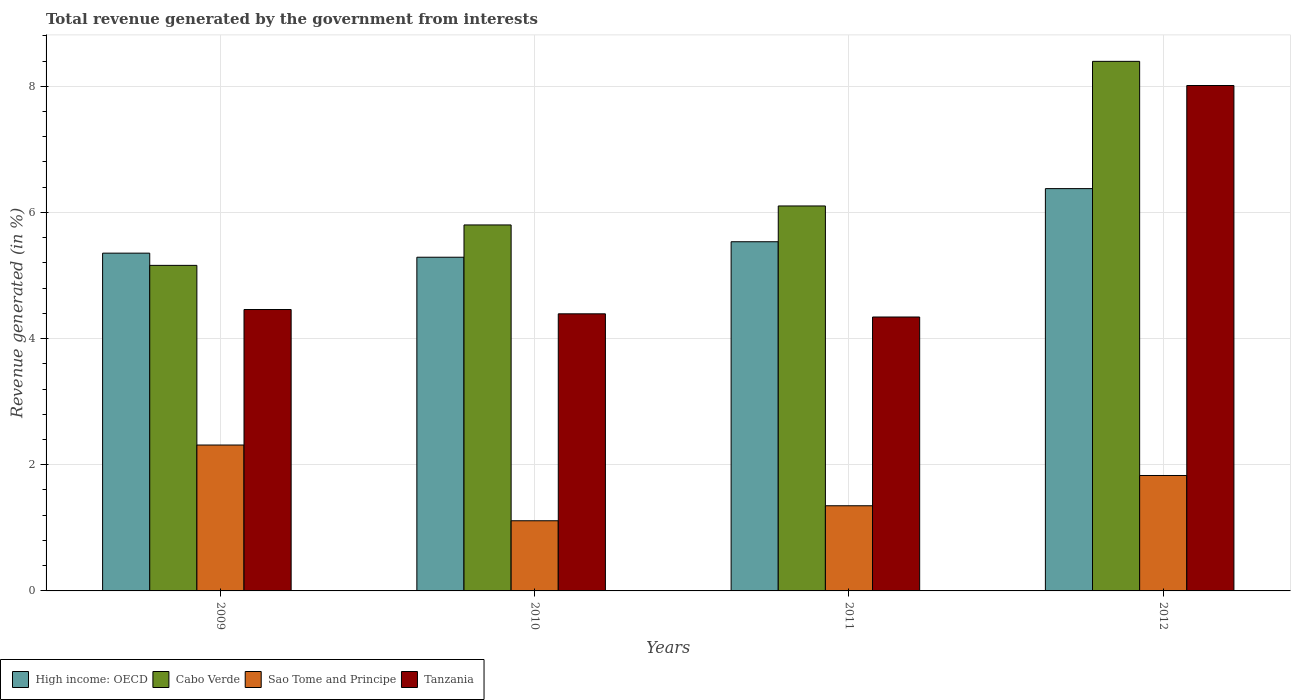How many different coloured bars are there?
Your answer should be very brief. 4. How many groups of bars are there?
Ensure brevity in your answer.  4. Are the number of bars on each tick of the X-axis equal?
Provide a short and direct response. Yes. How many bars are there on the 4th tick from the left?
Provide a succinct answer. 4. In how many cases, is the number of bars for a given year not equal to the number of legend labels?
Give a very brief answer. 0. What is the total revenue generated in Tanzania in 2011?
Keep it short and to the point. 4.34. Across all years, what is the maximum total revenue generated in Tanzania?
Your answer should be compact. 8.01. Across all years, what is the minimum total revenue generated in Sao Tome and Principe?
Ensure brevity in your answer.  1.11. In which year was the total revenue generated in Cabo Verde maximum?
Give a very brief answer. 2012. What is the total total revenue generated in Tanzania in the graph?
Your answer should be very brief. 21.21. What is the difference between the total revenue generated in Cabo Verde in 2011 and that in 2012?
Give a very brief answer. -2.29. What is the difference between the total revenue generated in Cabo Verde in 2011 and the total revenue generated in Sao Tome and Principe in 2012?
Offer a very short reply. 4.27. What is the average total revenue generated in Sao Tome and Principe per year?
Offer a terse response. 1.65. In the year 2009, what is the difference between the total revenue generated in Cabo Verde and total revenue generated in Tanzania?
Your answer should be very brief. 0.7. In how many years, is the total revenue generated in High income: OECD greater than 5.2 %?
Provide a succinct answer. 4. What is the ratio of the total revenue generated in Tanzania in 2010 to that in 2012?
Your answer should be compact. 0.55. Is the difference between the total revenue generated in Cabo Verde in 2009 and 2012 greater than the difference between the total revenue generated in Tanzania in 2009 and 2012?
Your answer should be compact. Yes. What is the difference between the highest and the second highest total revenue generated in High income: OECD?
Give a very brief answer. 0.84. What is the difference between the highest and the lowest total revenue generated in Sao Tome and Principe?
Provide a short and direct response. 1.2. In how many years, is the total revenue generated in High income: OECD greater than the average total revenue generated in High income: OECD taken over all years?
Your answer should be very brief. 1. Is the sum of the total revenue generated in Cabo Verde in 2009 and 2011 greater than the maximum total revenue generated in Tanzania across all years?
Your answer should be compact. Yes. What does the 2nd bar from the left in 2012 represents?
Your answer should be compact. Cabo Verde. What does the 3rd bar from the right in 2010 represents?
Offer a terse response. Cabo Verde. Are the values on the major ticks of Y-axis written in scientific E-notation?
Offer a very short reply. No. Does the graph contain any zero values?
Make the answer very short. No. Where does the legend appear in the graph?
Your response must be concise. Bottom left. What is the title of the graph?
Offer a very short reply. Total revenue generated by the government from interests. Does "Denmark" appear as one of the legend labels in the graph?
Your response must be concise. No. What is the label or title of the Y-axis?
Provide a succinct answer. Revenue generated (in %). What is the Revenue generated (in %) of High income: OECD in 2009?
Offer a terse response. 5.35. What is the Revenue generated (in %) of Cabo Verde in 2009?
Keep it short and to the point. 5.16. What is the Revenue generated (in %) in Sao Tome and Principe in 2009?
Make the answer very short. 2.31. What is the Revenue generated (in %) in Tanzania in 2009?
Give a very brief answer. 4.46. What is the Revenue generated (in %) of High income: OECD in 2010?
Provide a succinct answer. 5.29. What is the Revenue generated (in %) in Cabo Verde in 2010?
Keep it short and to the point. 5.8. What is the Revenue generated (in %) in Sao Tome and Principe in 2010?
Your answer should be very brief. 1.11. What is the Revenue generated (in %) of Tanzania in 2010?
Provide a short and direct response. 4.39. What is the Revenue generated (in %) of High income: OECD in 2011?
Offer a very short reply. 5.54. What is the Revenue generated (in %) of Cabo Verde in 2011?
Offer a very short reply. 6.1. What is the Revenue generated (in %) in Sao Tome and Principe in 2011?
Keep it short and to the point. 1.35. What is the Revenue generated (in %) of Tanzania in 2011?
Give a very brief answer. 4.34. What is the Revenue generated (in %) of High income: OECD in 2012?
Your answer should be compact. 6.38. What is the Revenue generated (in %) in Cabo Verde in 2012?
Keep it short and to the point. 8.4. What is the Revenue generated (in %) of Sao Tome and Principe in 2012?
Provide a succinct answer. 1.83. What is the Revenue generated (in %) in Tanzania in 2012?
Your answer should be compact. 8.01. Across all years, what is the maximum Revenue generated (in %) of High income: OECD?
Keep it short and to the point. 6.38. Across all years, what is the maximum Revenue generated (in %) in Cabo Verde?
Keep it short and to the point. 8.4. Across all years, what is the maximum Revenue generated (in %) of Sao Tome and Principe?
Give a very brief answer. 2.31. Across all years, what is the maximum Revenue generated (in %) of Tanzania?
Your answer should be very brief. 8.01. Across all years, what is the minimum Revenue generated (in %) in High income: OECD?
Your answer should be compact. 5.29. Across all years, what is the minimum Revenue generated (in %) in Cabo Verde?
Provide a short and direct response. 5.16. Across all years, what is the minimum Revenue generated (in %) of Sao Tome and Principe?
Provide a succinct answer. 1.11. Across all years, what is the minimum Revenue generated (in %) in Tanzania?
Give a very brief answer. 4.34. What is the total Revenue generated (in %) in High income: OECD in the graph?
Make the answer very short. 22.56. What is the total Revenue generated (in %) of Cabo Verde in the graph?
Your answer should be very brief. 25.46. What is the total Revenue generated (in %) in Sao Tome and Principe in the graph?
Offer a very short reply. 6.61. What is the total Revenue generated (in %) of Tanzania in the graph?
Your response must be concise. 21.21. What is the difference between the Revenue generated (in %) of High income: OECD in 2009 and that in 2010?
Keep it short and to the point. 0.06. What is the difference between the Revenue generated (in %) in Cabo Verde in 2009 and that in 2010?
Provide a short and direct response. -0.64. What is the difference between the Revenue generated (in %) of Sao Tome and Principe in 2009 and that in 2010?
Make the answer very short. 1.2. What is the difference between the Revenue generated (in %) in Tanzania in 2009 and that in 2010?
Provide a short and direct response. 0.07. What is the difference between the Revenue generated (in %) of High income: OECD in 2009 and that in 2011?
Your answer should be very brief. -0.18. What is the difference between the Revenue generated (in %) in Cabo Verde in 2009 and that in 2011?
Keep it short and to the point. -0.94. What is the difference between the Revenue generated (in %) of Sao Tome and Principe in 2009 and that in 2011?
Provide a succinct answer. 0.96. What is the difference between the Revenue generated (in %) of Tanzania in 2009 and that in 2011?
Offer a terse response. 0.12. What is the difference between the Revenue generated (in %) in High income: OECD in 2009 and that in 2012?
Ensure brevity in your answer.  -1.02. What is the difference between the Revenue generated (in %) of Cabo Verde in 2009 and that in 2012?
Provide a short and direct response. -3.23. What is the difference between the Revenue generated (in %) in Sao Tome and Principe in 2009 and that in 2012?
Your response must be concise. 0.48. What is the difference between the Revenue generated (in %) of Tanzania in 2009 and that in 2012?
Keep it short and to the point. -3.55. What is the difference between the Revenue generated (in %) in High income: OECD in 2010 and that in 2011?
Provide a short and direct response. -0.25. What is the difference between the Revenue generated (in %) of Cabo Verde in 2010 and that in 2011?
Provide a short and direct response. -0.3. What is the difference between the Revenue generated (in %) of Sao Tome and Principe in 2010 and that in 2011?
Your response must be concise. -0.24. What is the difference between the Revenue generated (in %) in Tanzania in 2010 and that in 2011?
Your answer should be compact. 0.05. What is the difference between the Revenue generated (in %) in High income: OECD in 2010 and that in 2012?
Make the answer very short. -1.09. What is the difference between the Revenue generated (in %) in Cabo Verde in 2010 and that in 2012?
Your answer should be compact. -2.59. What is the difference between the Revenue generated (in %) in Sao Tome and Principe in 2010 and that in 2012?
Provide a short and direct response. -0.72. What is the difference between the Revenue generated (in %) of Tanzania in 2010 and that in 2012?
Provide a short and direct response. -3.62. What is the difference between the Revenue generated (in %) of High income: OECD in 2011 and that in 2012?
Provide a succinct answer. -0.84. What is the difference between the Revenue generated (in %) in Cabo Verde in 2011 and that in 2012?
Your response must be concise. -2.29. What is the difference between the Revenue generated (in %) of Sao Tome and Principe in 2011 and that in 2012?
Offer a very short reply. -0.48. What is the difference between the Revenue generated (in %) of Tanzania in 2011 and that in 2012?
Offer a terse response. -3.67. What is the difference between the Revenue generated (in %) of High income: OECD in 2009 and the Revenue generated (in %) of Cabo Verde in 2010?
Give a very brief answer. -0.45. What is the difference between the Revenue generated (in %) of High income: OECD in 2009 and the Revenue generated (in %) of Sao Tome and Principe in 2010?
Offer a very short reply. 4.24. What is the difference between the Revenue generated (in %) in High income: OECD in 2009 and the Revenue generated (in %) in Tanzania in 2010?
Give a very brief answer. 0.96. What is the difference between the Revenue generated (in %) in Cabo Verde in 2009 and the Revenue generated (in %) in Sao Tome and Principe in 2010?
Provide a short and direct response. 4.05. What is the difference between the Revenue generated (in %) of Cabo Verde in 2009 and the Revenue generated (in %) of Tanzania in 2010?
Offer a terse response. 0.77. What is the difference between the Revenue generated (in %) of Sao Tome and Principe in 2009 and the Revenue generated (in %) of Tanzania in 2010?
Provide a succinct answer. -2.08. What is the difference between the Revenue generated (in %) of High income: OECD in 2009 and the Revenue generated (in %) of Cabo Verde in 2011?
Your answer should be very brief. -0.75. What is the difference between the Revenue generated (in %) of High income: OECD in 2009 and the Revenue generated (in %) of Sao Tome and Principe in 2011?
Provide a succinct answer. 4. What is the difference between the Revenue generated (in %) in High income: OECD in 2009 and the Revenue generated (in %) in Tanzania in 2011?
Give a very brief answer. 1.01. What is the difference between the Revenue generated (in %) in Cabo Verde in 2009 and the Revenue generated (in %) in Sao Tome and Principe in 2011?
Give a very brief answer. 3.81. What is the difference between the Revenue generated (in %) of Cabo Verde in 2009 and the Revenue generated (in %) of Tanzania in 2011?
Your answer should be compact. 0.82. What is the difference between the Revenue generated (in %) of Sao Tome and Principe in 2009 and the Revenue generated (in %) of Tanzania in 2011?
Offer a very short reply. -2.03. What is the difference between the Revenue generated (in %) of High income: OECD in 2009 and the Revenue generated (in %) of Cabo Verde in 2012?
Give a very brief answer. -3.04. What is the difference between the Revenue generated (in %) of High income: OECD in 2009 and the Revenue generated (in %) of Sao Tome and Principe in 2012?
Your answer should be compact. 3.52. What is the difference between the Revenue generated (in %) of High income: OECD in 2009 and the Revenue generated (in %) of Tanzania in 2012?
Provide a short and direct response. -2.66. What is the difference between the Revenue generated (in %) in Cabo Verde in 2009 and the Revenue generated (in %) in Sao Tome and Principe in 2012?
Make the answer very short. 3.33. What is the difference between the Revenue generated (in %) of Cabo Verde in 2009 and the Revenue generated (in %) of Tanzania in 2012?
Your answer should be very brief. -2.85. What is the difference between the Revenue generated (in %) in Sao Tome and Principe in 2009 and the Revenue generated (in %) in Tanzania in 2012?
Ensure brevity in your answer.  -5.7. What is the difference between the Revenue generated (in %) of High income: OECD in 2010 and the Revenue generated (in %) of Cabo Verde in 2011?
Make the answer very short. -0.81. What is the difference between the Revenue generated (in %) of High income: OECD in 2010 and the Revenue generated (in %) of Sao Tome and Principe in 2011?
Ensure brevity in your answer.  3.94. What is the difference between the Revenue generated (in %) of High income: OECD in 2010 and the Revenue generated (in %) of Tanzania in 2011?
Your response must be concise. 0.95. What is the difference between the Revenue generated (in %) of Cabo Verde in 2010 and the Revenue generated (in %) of Sao Tome and Principe in 2011?
Your response must be concise. 4.45. What is the difference between the Revenue generated (in %) of Cabo Verde in 2010 and the Revenue generated (in %) of Tanzania in 2011?
Make the answer very short. 1.46. What is the difference between the Revenue generated (in %) in Sao Tome and Principe in 2010 and the Revenue generated (in %) in Tanzania in 2011?
Give a very brief answer. -3.23. What is the difference between the Revenue generated (in %) of High income: OECD in 2010 and the Revenue generated (in %) of Cabo Verde in 2012?
Your answer should be compact. -3.11. What is the difference between the Revenue generated (in %) in High income: OECD in 2010 and the Revenue generated (in %) in Sao Tome and Principe in 2012?
Keep it short and to the point. 3.46. What is the difference between the Revenue generated (in %) in High income: OECD in 2010 and the Revenue generated (in %) in Tanzania in 2012?
Provide a short and direct response. -2.72. What is the difference between the Revenue generated (in %) in Cabo Verde in 2010 and the Revenue generated (in %) in Sao Tome and Principe in 2012?
Make the answer very short. 3.97. What is the difference between the Revenue generated (in %) of Cabo Verde in 2010 and the Revenue generated (in %) of Tanzania in 2012?
Provide a short and direct response. -2.21. What is the difference between the Revenue generated (in %) of High income: OECD in 2011 and the Revenue generated (in %) of Cabo Verde in 2012?
Provide a succinct answer. -2.86. What is the difference between the Revenue generated (in %) in High income: OECD in 2011 and the Revenue generated (in %) in Sao Tome and Principe in 2012?
Your response must be concise. 3.71. What is the difference between the Revenue generated (in %) of High income: OECD in 2011 and the Revenue generated (in %) of Tanzania in 2012?
Offer a terse response. -2.48. What is the difference between the Revenue generated (in %) in Cabo Verde in 2011 and the Revenue generated (in %) in Sao Tome and Principe in 2012?
Provide a short and direct response. 4.27. What is the difference between the Revenue generated (in %) of Cabo Verde in 2011 and the Revenue generated (in %) of Tanzania in 2012?
Give a very brief answer. -1.91. What is the difference between the Revenue generated (in %) in Sao Tome and Principe in 2011 and the Revenue generated (in %) in Tanzania in 2012?
Your answer should be very brief. -6.66. What is the average Revenue generated (in %) of High income: OECD per year?
Give a very brief answer. 5.64. What is the average Revenue generated (in %) of Cabo Verde per year?
Offer a very short reply. 6.37. What is the average Revenue generated (in %) of Sao Tome and Principe per year?
Offer a terse response. 1.65. What is the average Revenue generated (in %) of Tanzania per year?
Provide a short and direct response. 5.3. In the year 2009, what is the difference between the Revenue generated (in %) in High income: OECD and Revenue generated (in %) in Cabo Verde?
Your answer should be very brief. 0.19. In the year 2009, what is the difference between the Revenue generated (in %) in High income: OECD and Revenue generated (in %) in Sao Tome and Principe?
Your response must be concise. 3.04. In the year 2009, what is the difference between the Revenue generated (in %) in High income: OECD and Revenue generated (in %) in Tanzania?
Provide a short and direct response. 0.89. In the year 2009, what is the difference between the Revenue generated (in %) in Cabo Verde and Revenue generated (in %) in Sao Tome and Principe?
Your answer should be compact. 2.85. In the year 2009, what is the difference between the Revenue generated (in %) in Cabo Verde and Revenue generated (in %) in Tanzania?
Provide a short and direct response. 0.7. In the year 2009, what is the difference between the Revenue generated (in %) in Sao Tome and Principe and Revenue generated (in %) in Tanzania?
Provide a succinct answer. -2.15. In the year 2010, what is the difference between the Revenue generated (in %) of High income: OECD and Revenue generated (in %) of Cabo Verde?
Provide a short and direct response. -0.51. In the year 2010, what is the difference between the Revenue generated (in %) in High income: OECD and Revenue generated (in %) in Sao Tome and Principe?
Your response must be concise. 4.18. In the year 2010, what is the difference between the Revenue generated (in %) of High income: OECD and Revenue generated (in %) of Tanzania?
Offer a terse response. 0.9. In the year 2010, what is the difference between the Revenue generated (in %) of Cabo Verde and Revenue generated (in %) of Sao Tome and Principe?
Make the answer very short. 4.69. In the year 2010, what is the difference between the Revenue generated (in %) in Cabo Verde and Revenue generated (in %) in Tanzania?
Keep it short and to the point. 1.41. In the year 2010, what is the difference between the Revenue generated (in %) of Sao Tome and Principe and Revenue generated (in %) of Tanzania?
Give a very brief answer. -3.28. In the year 2011, what is the difference between the Revenue generated (in %) of High income: OECD and Revenue generated (in %) of Cabo Verde?
Your response must be concise. -0.57. In the year 2011, what is the difference between the Revenue generated (in %) of High income: OECD and Revenue generated (in %) of Sao Tome and Principe?
Your response must be concise. 4.19. In the year 2011, what is the difference between the Revenue generated (in %) of High income: OECD and Revenue generated (in %) of Tanzania?
Give a very brief answer. 1.19. In the year 2011, what is the difference between the Revenue generated (in %) of Cabo Verde and Revenue generated (in %) of Sao Tome and Principe?
Give a very brief answer. 4.75. In the year 2011, what is the difference between the Revenue generated (in %) of Cabo Verde and Revenue generated (in %) of Tanzania?
Offer a terse response. 1.76. In the year 2011, what is the difference between the Revenue generated (in %) of Sao Tome and Principe and Revenue generated (in %) of Tanzania?
Give a very brief answer. -2.99. In the year 2012, what is the difference between the Revenue generated (in %) of High income: OECD and Revenue generated (in %) of Cabo Verde?
Make the answer very short. -2.02. In the year 2012, what is the difference between the Revenue generated (in %) in High income: OECD and Revenue generated (in %) in Sao Tome and Principe?
Make the answer very short. 4.55. In the year 2012, what is the difference between the Revenue generated (in %) in High income: OECD and Revenue generated (in %) in Tanzania?
Offer a terse response. -1.63. In the year 2012, what is the difference between the Revenue generated (in %) of Cabo Verde and Revenue generated (in %) of Sao Tome and Principe?
Ensure brevity in your answer.  6.57. In the year 2012, what is the difference between the Revenue generated (in %) of Cabo Verde and Revenue generated (in %) of Tanzania?
Make the answer very short. 0.38. In the year 2012, what is the difference between the Revenue generated (in %) of Sao Tome and Principe and Revenue generated (in %) of Tanzania?
Provide a succinct answer. -6.18. What is the ratio of the Revenue generated (in %) in High income: OECD in 2009 to that in 2010?
Offer a very short reply. 1.01. What is the ratio of the Revenue generated (in %) of Cabo Verde in 2009 to that in 2010?
Provide a succinct answer. 0.89. What is the ratio of the Revenue generated (in %) in Sao Tome and Principe in 2009 to that in 2010?
Provide a succinct answer. 2.08. What is the ratio of the Revenue generated (in %) in Tanzania in 2009 to that in 2010?
Offer a terse response. 1.02. What is the ratio of the Revenue generated (in %) of High income: OECD in 2009 to that in 2011?
Your answer should be compact. 0.97. What is the ratio of the Revenue generated (in %) of Cabo Verde in 2009 to that in 2011?
Offer a very short reply. 0.85. What is the ratio of the Revenue generated (in %) in Sao Tome and Principe in 2009 to that in 2011?
Provide a succinct answer. 1.71. What is the ratio of the Revenue generated (in %) in Tanzania in 2009 to that in 2011?
Ensure brevity in your answer.  1.03. What is the ratio of the Revenue generated (in %) in High income: OECD in 2009 to that in 2012?
Ensure brevity in your answer.  0.84. What is the ratio of the Revenue generated (in %) in Cabo Verde in 2009 to that in 2012?
Offer a terse response. 0.61. What is the ratio of the Revenue generated (in %) of Sao Tome and Principe in 2009 to that in 2012?
Your answer should be very brief. 1.26. What is the ratio of the Revenue generated (in %) in Tanzania in 2009 to that in 2012?
Offer a very short reply. 0.56. What is the ratio of the Revenue generated (in %) of High income: OECD in 2010 to that in 2011?
Ensure brevity in your answer.  0.96. What is the ratio of the Revenue generated (in %) of Cabo Verde in 2010 to that in 2011?
Ensure brevity in your answer.  0.95. What is the ratio of the Revenue generated (in %) of Sao Tome and Principe in 2010 to that in 2011?
Provide a succinct answer. 0.82. What is the ratio of the Revenue generated (in %) of Tanzania in 2010 to that in 2011?
Offer a terse response. 1.01. What is the ratio of the Revenue generated (in %) of High income: OECD in 2010 to that in 2012?
Your answer should be very brief. 0.83. What is the ratio of the Revenue generated (in %) of Cabo Verde in 2010 to that in 2012?
Make the answer very short. 0.69. What is the ratio of the Revenue generated (in %) of Sao Tome and Principe in 2010 to that in 2012?
Make the answer very short. 0.61. What is the ratio of the Revenue generated (in %) of Tanzania in 2010 to that in 2012?
Provide a short and direct response. 0.55. What is the ratio of the Revenue generated (in %) in High income: OECD in 2011 to that in 2012?
Offer a terse response. 0.87. What is the ratio of the Revenue generated (in %) of Cabo Verde in 2011 to that in 2012?
Ensure brevity in your answer.  0.73. What is the ratio of the Revenue generated (in %) in Sao Tome and Principe in 2011 to that in 2012?
Your response must be concise. 0.74. What is the ratio of the Revenue generated (in %) in Tanzania in 2011 to that in 2012?
Make the answer very short. 0.54. What is the difference between the highest and the second highest Revenue generated (in %) in High income: OECD?
Your answer should be very brief. 0.84. What is the difference between the highest and the second highest Revenue generated (in %) of Cabo Verde?
Your answer should be very brief. 2.29. What is the difference between the highest and the second highest Revenue generated (in %) of Sao Tome and Principe?
Provide a short and direct response. 0.48. What is the difference between the highest and the second highest Revenue generated (in %) in Tanzania?
Provide a short and direct response. 3.55. What is the difference between the highest and the lowest Revenue generated (in %) of High income: OECD?
Make the answer very short. 1.09. What is the difference between the highest and the lowest Revenue generated (in %) in Cabo Verde?
Offer a terse response. 3.23. What is the difference between the highest and the lowest Revenue generated (in %) of Sao Tome and Principe?
Provide a short and direct response. 1.2. What is the difference between the highest and the lowest Revenue generated (in %) of Tanzania?
Your response must be concise. 3.67. 